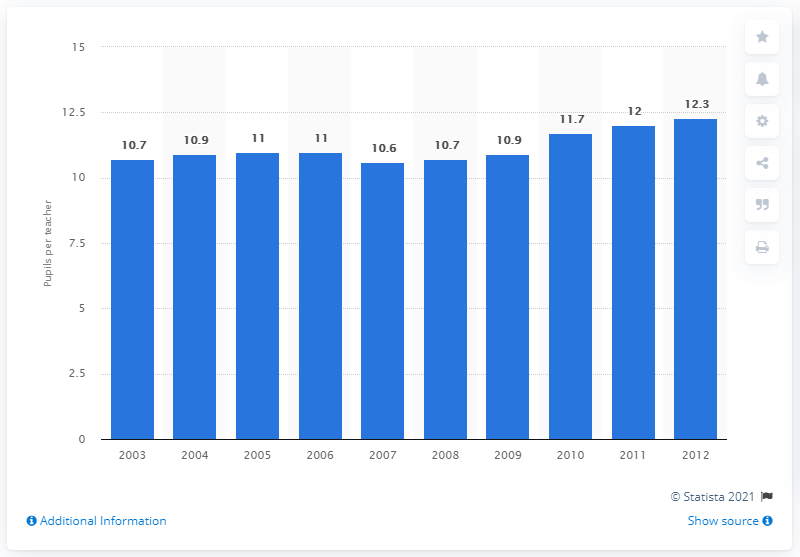Indicate a few pertinent items in this graphic. In 2012, the average number of students per teacher in Italy was 12.3. 